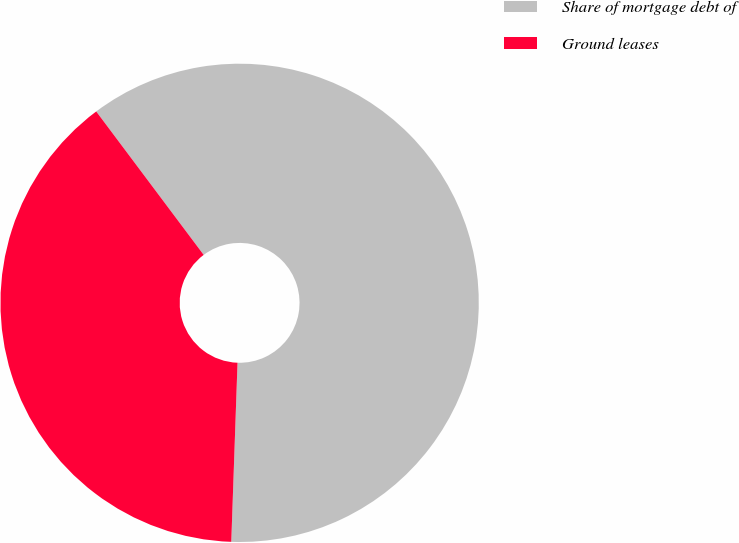<chart> <loc_0><loc_0><loc_500><loc_500><pie_chart><fcel>Share of mortgage debt of<fcel>Ground leases<nl><fcel>60.79%<fcel>39.21%<nl></chart> 